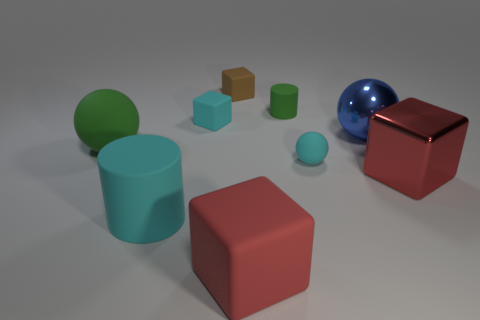What is the shape of the large object that is the same color as the metal block?
Give a very brief answer. Cube. What is the shape of the red metal thing that is the same size as the blue metal sphere?
Provide a succinct answer. Cube. There is a big object that is the same color as the metal block; what material is it?
Your answer should be compact. Rubber. There is a large green object; are there any small cyan things in front of it?
Your response must be concise. Yes. Is there a red matte thing that has the same shape as the brown rubber thing?
Your answer should be very brief. Yes. Is the shape of the small cyan matte object that is in front of the large green rubber sphere the same as the green object to the right of the brown thing?
Offer a terse response. No. Is there a red metallic block of the same size as the shiny sphere?
Make the answer very short. Yes. Are there an equal number of small things to the left of the large green matte thing and tiny brown cubes in front of the small cyan ball?
Make the answer very short. Yes. Are the small cyan object on the left side of the tiny brown thing and the big block that is behind the cyan cylinder made of the same material?
Make the answer very short. No. What is the blue thing made of?
Provide a short and direct response. Metal. 